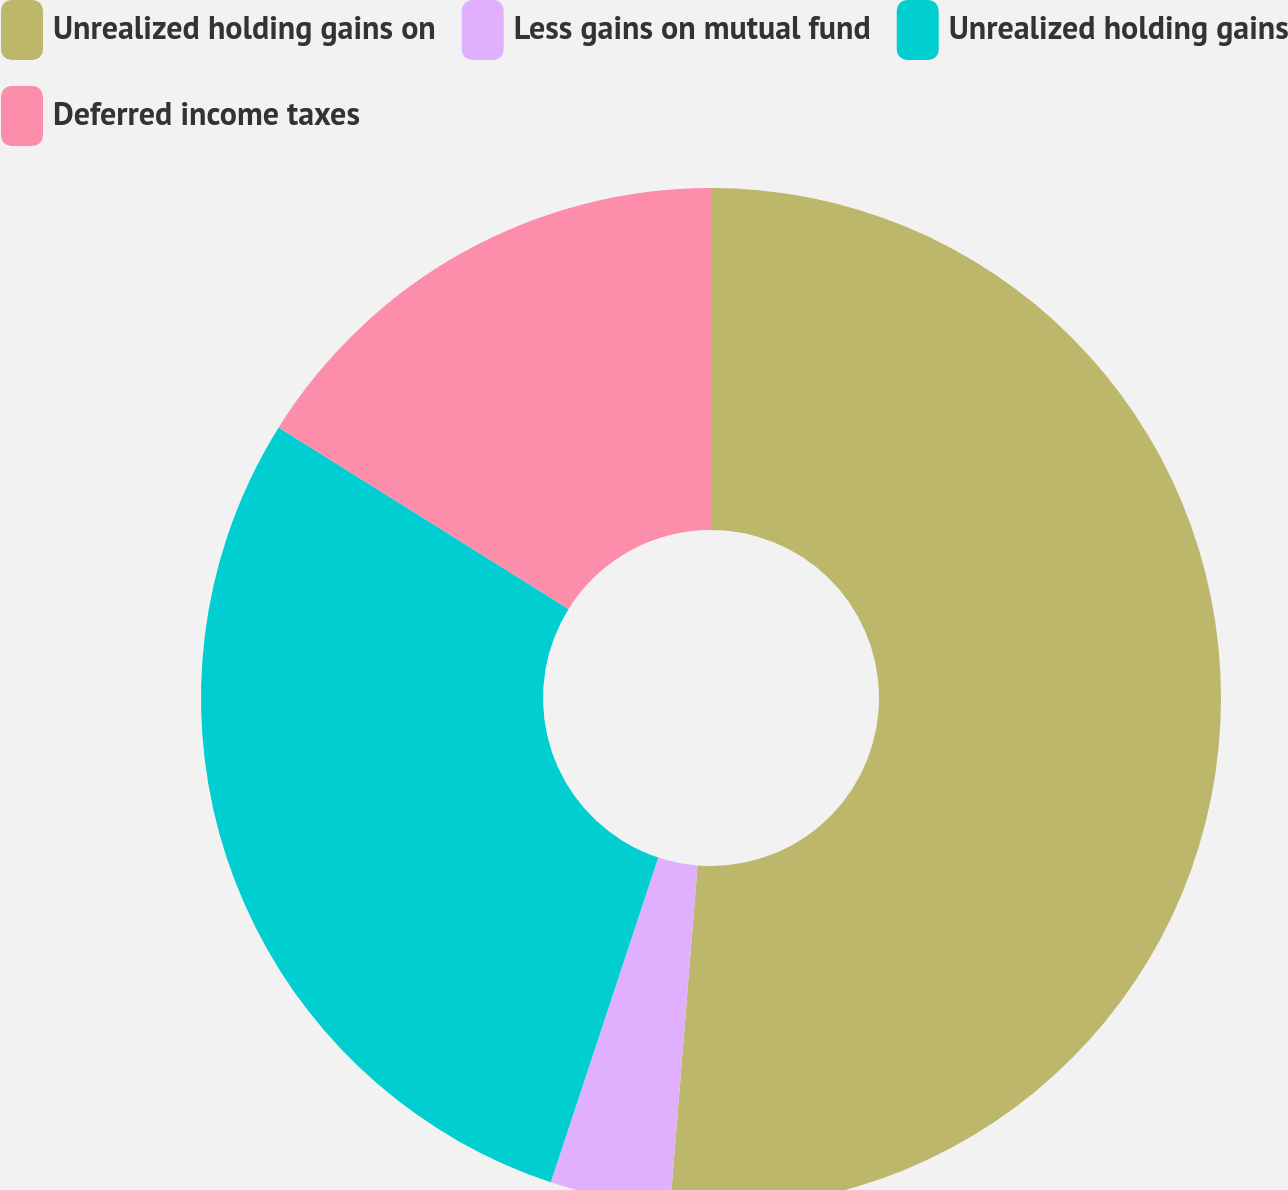<chart> <loc_0><loc_0><loc_500><loc_500><pie_chart><fcel>Unrealized holding gains on<fcel>Less gains on mutual fund<fcel>Unrealized holding gains<fcel>Deferred income taxes<nl><fcel>51.27%<fcel>3.81%<fcel>28.81%<fcel>16.1%<nl></chart> 